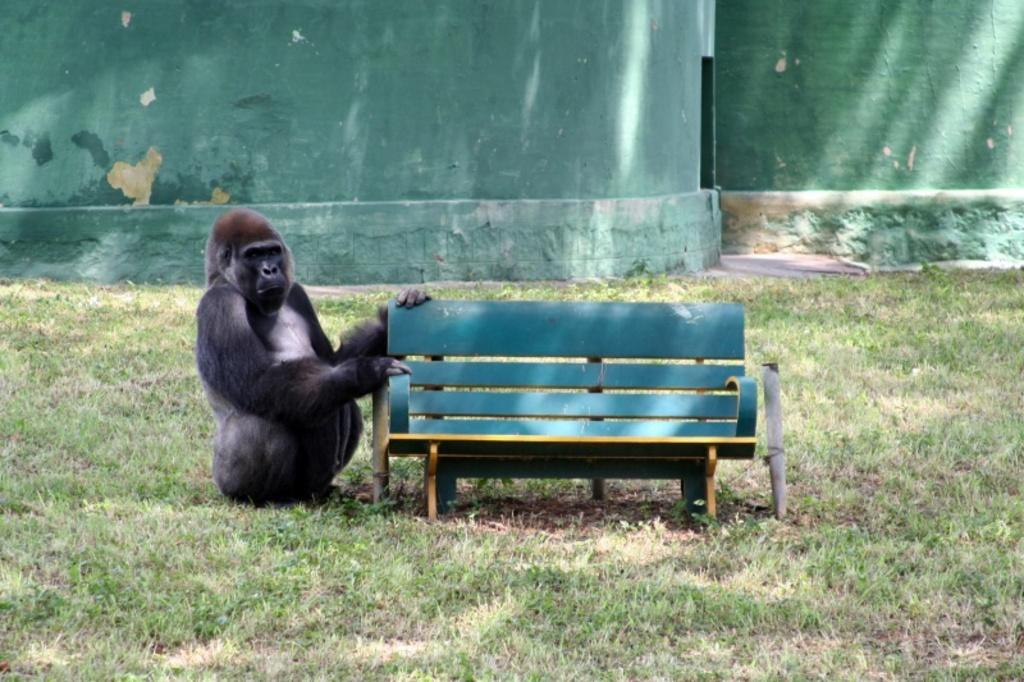What animal is present in the image? There is a chimpanzee in the image. Where is the chimpanzee located in relation to other objects? The chimpanzee is sitting near a bench. What type of ground surface is visible at the bottom of the image? There is grass visible at the bottom of the image. What color is the wall in the background of the image? There is a green wall in the background of the image. How does the expert treat the chimpanzee's wound in the image? There is no expert or wound present in the image; it only features a chimpanzee sitting near a bench. 